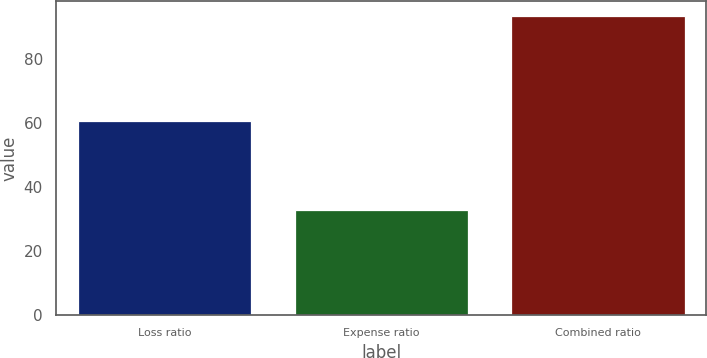<chart> <loc_0><loc_0><loc_500><loc_500><bar_chart><fcel>Loss ratio<fcel>Expense ratio<fcel>Combined ratio<nl><fcel>60.6<fcel>32.9<fcel>93.5<nl></chart> 